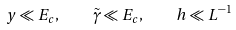<formula> <loc_0><loc_0><loc_500><loc_500>y \ll E _ { c } , \quad \tilde { \gamma } \ll E _ { c } , \quad h \ll L ^ { - 1 }</formula> 